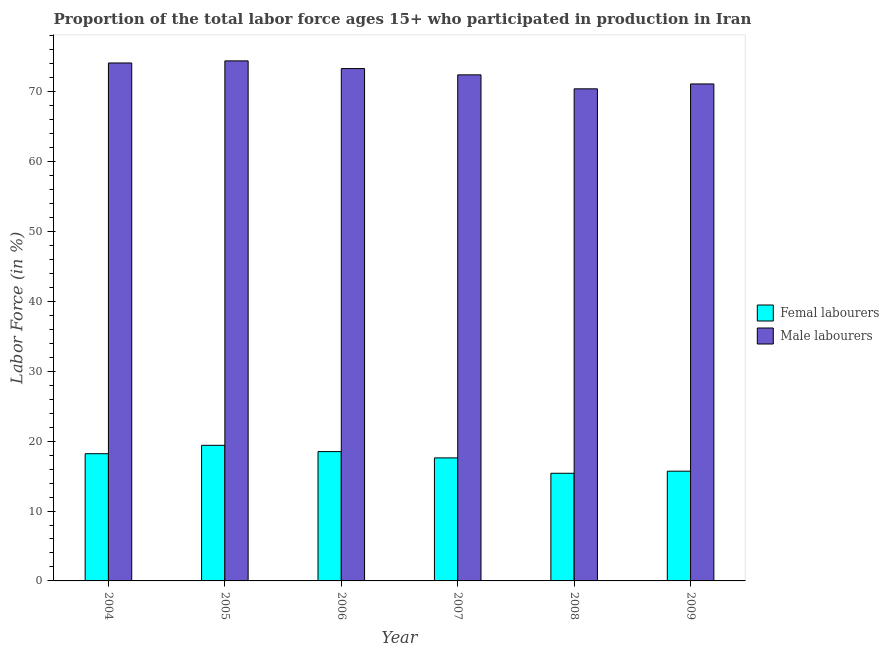How many groups of bars are there?
Provide a short and direct response. 6. Are the number of bars per tick equal to the number of legend labels?
Your answer should be very brief. Yes. Are the number of bars on each tick of the X-axis equal?
Provide a short and direct response. Yes. What is the label of the 1st group of bars from the left?
Your response must be concise. 2004. In how many cases, is the number of bars for a given year not equal to the number of legend labels?
Make the answer very short. 0. What is the percentage of male labour force in 2007?
Give a very brief answer. 72.4. Across all years, what is the maximum percentage of male labour force?
Offer a terse response. 74.4. Across all years, what is the minimum percentage of female labor force?
Make the answer very short. 15.4. In which year was the percentage of female labor force maximum?
Your answer should be very brief. 2005. What is the total percentage of female labor force in the graph?
Your response must be concise. 104.8. What is the difference between the percentage of male labour force in 2004 and that in 2009?
Offer a terse response. 3. What is the difference between the percentage of female labor force in 2008 and the percentage of male labour force in 2007?
Provide a short and direct response. -2.2. What is the average percentage of female labor force per year?
Ensure brevity in your answer.  17.47. In the year 2007, what is the difference between the percentage of female labor force and percentage of male labour force?
Your answer should be very brief. 0. In how many years, is the percentage of female labor force greater than 20 %?
Provide a short and direct response. 0. What is the ratio of the percentage of male labour force in 2006 to that in 2008?
Keep it short and to the point. 1.04. Is the percentage of female labor force in 2005 less than that in 2006?
Ensure brevity in your answer.  No. What is the difference between the highest and the second highest percentage of male labour force?
Give a very brief answer. 0.3. What is the difference between the highest and the lowest percentage of female labor force?
Provide a short and direct response. 4. What does the 2nd bar from the left in 2004 represents?
Your response must be concise. Male labourers. What does the 1st bar from the right in 2006 represents?
Offer a very short reply. Male labourers. How many bars are there?
Keep it short and to the point. 12. What is the difference between two consecutive major ticks on the Y-axis?
Give a very brief answer. 10. Does the graph contain any zero values?
Your answer should be very brief. No. Does the graph contain grids?
Keep it short and to the point. No. Where does the legend appear in the graph?
Offer a terse response. Center right. How many legend labels are there?
Ensure brevity in your answer.  2. What is the title of the graph?
Keep it short and to the point. Proportion of the total labor force ages 15+ who participated in production in Iran. What is the label or title of the Y-axis?
Provide a succinct answer. Labor Force (in %). What is the Labor Force (in %) of Femal labourers in 2004?
Provide a short and direct response. 18.2. What is the Labor Force (in %) in Male labourers in 2004?
Offer a very short reply. 74.1. What is the Labor Force (in %) in Femal labourers in 2005?
Provide a short and direct response. 19.4. What is the Labor Force (in %) of Male labourers in 2005?
Provide a short and direct response. 74.4. What is the Labor Force (in %) in Male labourers in 2006?
Provide a succinct answer. 73.3. What is the Labor Force (in %) of Femal labourers in 2007?
Your response must be concise. 17.6. What is the Labor Force (in %) of Male labourers in 2007?
Offer a terse response. 72.4. What is the Labor Force (in %) in Femal labourers in 2008?
Your response must be concise. 15.4. What is the Labor Force (in %) in Male labourers in 2008?
Offer a terse response. 70.4. What is the Labor Force (in %) in Femal labourers in 2009?
Offer a terse response. 15.7. What is the Labor Force (in %) in Male labourers in 2009?
Your answer should be compact. 71.1. Across all years, what is the maximum Labor Force (in %) of Femal labourers?
Make the answer very short. 19.4. Across all years, what is the maximum Labor Force (in %) of Male labourers?
Provide a succinct answer. 74.4. Across all years, what is the minimum Labor Force (in %) of Femal labourers?
Your answer should be compact. 15.4. Across all years, what is the minimum Labor Force (in %) of Male labourers?
Provide a short and direct response. 70.4. What is the total Labor Force (in %) in Femal labourers in the graph?
Make the answer very short. 104.8. What is the total Labor Force (in %) in Male labourers in the graph?
Your answer should be very brief. 435.7. What is the difference between the Labor Force (in %) in Femal labourers in 2004 and that in 2005?
Offer a terse response. -1.2. What is the difference between the Labor Force (in %) in Male labourers in 2004 and that in 2005?
Your answer should be very brief. -0.3. What is the difference between the Labor Force (in %) of Male labourers in 2004 and that in 2006?
Give a very brief answer. 0.8. What is the difference between the Labor Force (in %) in Femal labourers in 2004 and that in 2007?
Your response must be concise. 0.6. What is the difference between the Labor Force (in %) of Male labourers in 2004 and that in 2007?
Provide a succinct answer. 1.7. What is the difference between the Labor Force (in %) in Femal labourers in 2004 and that in 2008?
Give a very brief answer. 2.8. What is the difference between the Labor Force (in %) of Femal labourers in 2005 and that in 2006?
Provide a short and direct response. 0.9. What is the difference between the Labor Force (in %) in Male labourers in 2005 and that in 2008?
Give a very brief answer. 4. What is the difference between the Labor Force (in %) of Male labourers in 2006 and that in 2007?
Give a very brief answer. 0.9. What is the difference between the Labor Force (in %) of Male labourers in 2007 and that in 2008?
Provide a succinct answer. 2. What is the difference between the Labor Force (in %) in Femal labourers in 2007 and that in 2009?
Your answer should be compact. 1.9. What is the difference between the Labor Force (in %) of Male labourers in 2008 and that in 2009?
Your response must be concise. -0.7. What is the difference between the Labor Force (in %) in Femal labourers in 2004 and the Labor Force (in %) in Male labourers in 2005?
Give a very brief answer. -56.2. What is the difference between the Labor Force (in %) in Femal labourers in 2004 and the Labor Force (in %) in Male labourers in 2006?
Your answer should be compact. -55.1. What is the difference between the Labor Force (in %) of Femal labourers in 2004 and the Labor Force (in %) of Male labourers in 2007?
Your response must be concise. -54.2. What is the difference between the Labor Force (in %) in Femal labourers in 2004 and the Labor Force (in %) in Male labourers in 2008?
Your answer should be compact. -52.2. What is the difference between the Labor Force (in %) of Femal labourers in 2004 and the Labor Force (in %) of Male labourers in 2009?
Provide a succinct answer. -52.9. What is the difference between the Labor Force (in %) of Femal labourers in 2005 and the Labor Force (in %) of Male labourers in 2006?
Give a very brief answer. -53.9. What is the difference between the Labor Force (in %) of Femal labourers in 2005 and the Labor Force (in %) of Male labourers in 2007?
Offer a terse response. -53. What is the difference between the Labor Force (in %) in Femal labourers in 2005 and the Labor Force (in %) in Male labourers in 2008?
Give a very brief answer. -51. What is the difference between the Labor Force (in %) in Femal labourers in 2005 and the Labor Force (in %) in Male labourers in 2009?
Give a very brief answer. -51.7. What is the difference between the Labor Force (in %) of Femal labourers in 2006 and the Labor Force (in %) of Male labourers in 2007?
Your answer should be very brief. -53.9. What is the difference between the Labor Force (in %) in Femal labourers in 2006 and the Labor Force (in %) in Male labourers in 2008?
Keep it short and to the point. -51.9. What is the difference between the Labor Force (in %) of Femal labourers in 2006 and the Labor Force (in %) of Male labourers in 2009?
Make the answer very short. -52.6. What is the difference between the Labor Force (in %) in Femal labourers in 2007 and the Labor Force (in %) in Male labourers in 2008?
Make the answer very short. -52.8. What is the difference between the Labor Force (in %) in Femal labourers in 2007 and the Labor Force (in %) in Male labourers in 2009?
Your answer should be compact. -53.5. What is the difference between the Labor Force (in %) in Femal labourers in 2008 and the Labor Force (in %) in Male labourers in 2009?
Your response must be concise. -55.7. What is the average Labor Force (in %) in Femal labourers per year?
Provide a succinct answer. 17.47. What is the average Labor Force (in %) of Male labourers per year?
Your answer should be very brief. 72.62. In the year 2004, what is the difference between the Labor Force (in %) of Femal labourers and Labor Force (in %) of Male labourers?
Your answer should be compact. -55.9. In the year 2005, what is the difference between the Labor Force (in %) in Femal labourers and Labor Force (in %) in Male labourers?
Provide a succinct answer. -55. In the year 2006, what is the difference between the Labor Force (in %) of Femal labourers and Labor Force (in %) of Male labourers?
Your answer should be very brief. -54.8. In the year 2007, what is the difference between the Labor Force (in %) in Femal labourers and Labor Force (in %) in Male labourers?
Make the answer very short. -54.8. In the year 2008, what is the difference between the Labor Force (in %) of Femal labourers and Labor Force (in %) of Male labourers?
Ensure brevity in your answer.  -55. In the year 2009, what is the difference between the Labor Force (in %) in Femal labourers and Labor Force (in %) in Male labourers?
Keep it short and to the point. -55.4. What is the ratio of the Labor Force (in %) in Femal labourers in 2004 to that in 2005?
Provide a succinct answer. 0.94. What is the ratio of the Labor Force (in %) of Male labourers in 2004 to that in 2005?
Ensure brevity in your answer.  1. What is the ratio of the Labor Force (in %) of Femal labourers in 2004 to that in 2006?
Give a very brief answer. 0.98. What is the ratio of the Labor Force (in %) of Male labourers in 2004 to that in 2006?
Keep it short and to the point. 1.01. What is the ratio of the Labor Force (in %) of Femal labourers in 2004 to that in 2007?
Provide a succinct answer. 1.03. What is the ratio of the Labor Force (in %) in Male labourers in 2004 to that in 2007?
Your answer should be compact. 1.02. What is the ratio of the Labor Force (in %) in Femal labourers in 2004 to that in 2008?
Your response must be concise. 1.18. What is the ratio of the Labor Force (in %) of Male labourers in 2004 to that in 2008?
Ensure brevity in your answer.  1.05. What is the ratio of the Labor Force (in %) of Femal labourers in 2004 to that in 2009?
Ensure brevity in your answer.  1.16. What is the ratio of the Labor Force (in %) in Male labourers in 2004 to that in 2009?
Your answer should be very brief. 1.04. What is the ratio of the Labor Force (in %) in Femal labourers in 2005 to that in 2006?
Offer a terse response. 1.05. What is the ratio of the Labor Force (in %) in Femal labourers in 2005 to that in 2007?
Your answer should be very brief. 1.1. What is the ratio of the Labor Force (in %) in Male labourers in 2005 to that in 2007?
Keep it short and to the point. 1.03. What is the ratio of the Labor Force (in %) in Femal labourers in 2005 to that in 2008?
Your answer should be compact. 1.26. What is the ratio of the Labor Force (in %) of Male labourers in 2005 to that in 2008?
Ensure brevity in your answer.  1.06. What is the ratio of the Labor Force (in %) of Femal labourers in 2005 to that in 2009?
Your answer should be very brief. 1.24. What is the ratio of the Labor Force (in %) in Male labourers in 2005 to that in 2009?
Ensure brevity in your answer.  1.05. What is the ratio of the Labor Force (in %) of Femal labourers in 2006 to that in 2007?
Ensure brevity in your answer.  1.05. What is the ratio of the Labor Force (in %) in Male labourers in 2006 to that in 2007?
Make the answer very short. 1.01. What is the ratio of the Labor Force (in %) in Femal labourers in 2006 to that in 2008?
Your response must be concise. 1.2. What is the ratio of the Labor Force (in %) in Male labourers in 2006 to that in 2008?
Make the answer very short. 1.04. What is the ratio of the Labor Force (in %) in Femal labourers in 2006 to that in 2009?
Provide a succinct answer. 1.18. What is the ratio of the Labor Force (in %) in Male labourers in 2006 to that in 2009?
Ensure brevity in your answer.  1.03. What is the ratio of the Labor Force (in %) of Femal labourers in 2007 to that in 2008?
Provide a succinct answer. 1.14. What is the ratio of the Labor Force (in %) of Male labourers in 2007 to that in 2008?
Offer a very short reply. 1.03. What is the ratio of the Labor Force (in %) of Femal labourers in 2007 to that in 2009?
Make the answer very short. 1.12. What is the ratio of the Labor Force (in %) in Male labourers in 2007 to that in 2009?
Your answer should be very brief. 1.02. What is the ratio of the Labor Force (in %) of Femal labourers in 2008 to that in 2009?
Your answer should be compact. 0.98. What is the ratio of the Labor Force (in %) in Male labourers in 2008 to that in 2009?
Offer a very short reply. 0.99. What is the difference between the highest and the second highest Labor Force (in %) of Male labourers?
Offer a very short reply. 0.3. What is the difference between the highest and the lowest Labor Force (in %) of Male labourers?
Offer a very short reply. 4. 